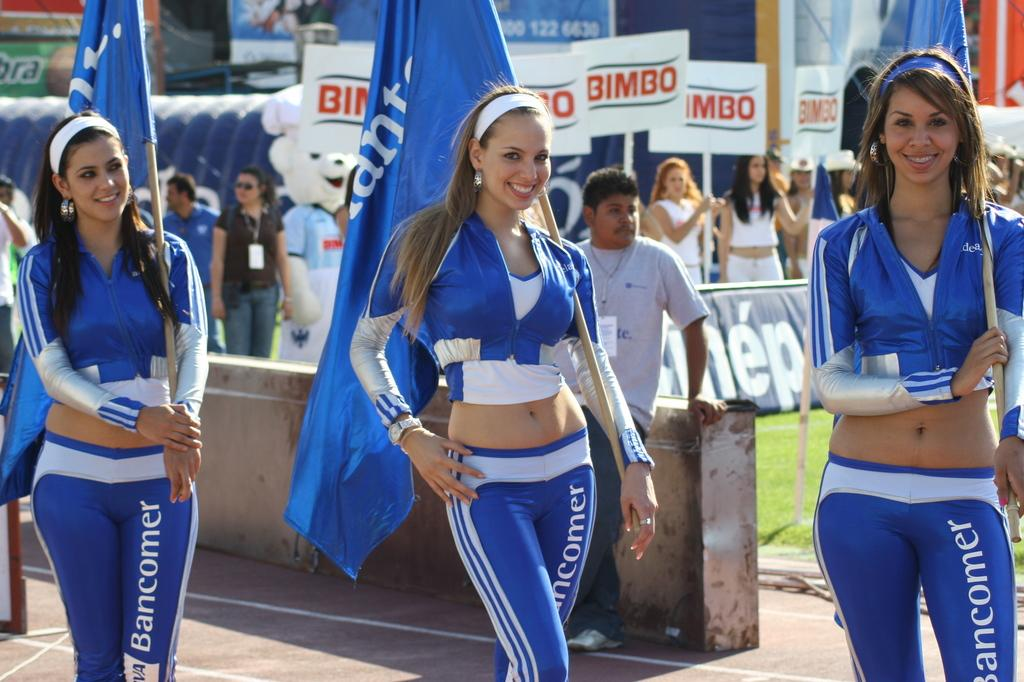<image>
Summarize the visual content of the image. Three promo girls for bancomer wearing blue tight uniforms are posing for the picture. 